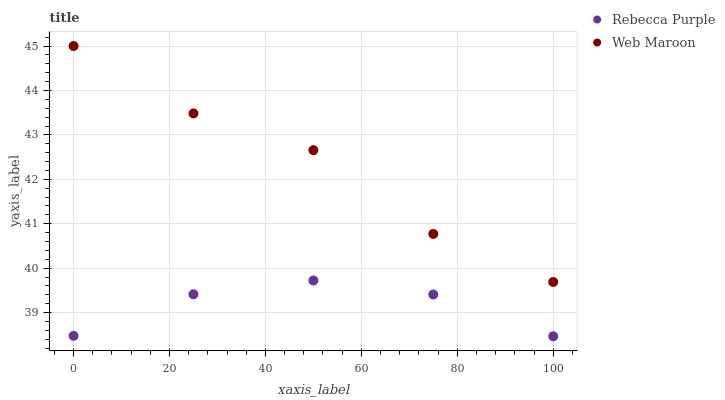Does Rebecca Purple have the minimum area under the curve?
Answer yes or no. Yes. Does Web Maroon have the maximum area under the curve?
Answer yes or no. Yes. Does Rebecca Purple have the maximum area under the curve?
Answer yes or no. No. Is Rebecca Purple the smoothest?
Answer yes or no. Yes. Is Web Maroon the roughest?
Answer yes or no. Yes. Is Rebecca Purple the roughest?
Answer yes or no. No. Does Rebecca Purple have the lowest value?
Answer yes or no. Yes. Does Web Maroon have the highest value?
Answer yes or no. Yes. Does Rebecca Purple have the highest value?
Answer yes or no. No. Is Rebecca Purple less than Web Maroon?
Answer yes or no. Yes. Is Web Maroon greater than Rebecca Purple?
Answer yes or no. Yes. Does Rebecca Purple intersect Web Maroon?
Answer yes or no. No. 